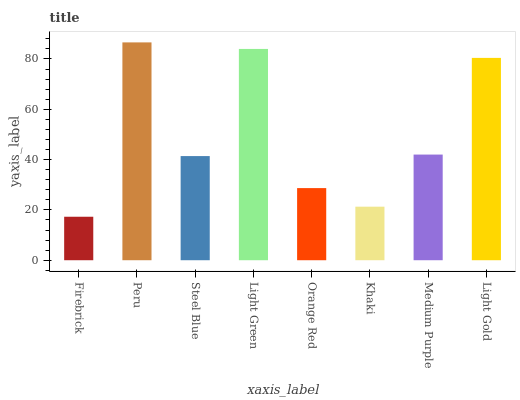Is Steel Blue the minimum?
Answer yes or no. No. Is Steel Blue the maximum?
Answer yes or no. No. Is Peru greater than Steel Blue?
Answer yes or no. Yes. Is Steel Blue less than Peru?
Answer yes or no. Yes. Is Steel Blue greater than Peru?
Answer yes or no. No. Is Peru less than Steel Blue?
Answer yes or no. No. Is Medium Purple the high median?
Answer yes or no. Yes. Is Steel Blue the low median?
Answer yes or no. Yes. Is Orange Red the high median?
Answer yes or no. No. Is Medium Purple the low median?
Answer yes or no. No. 